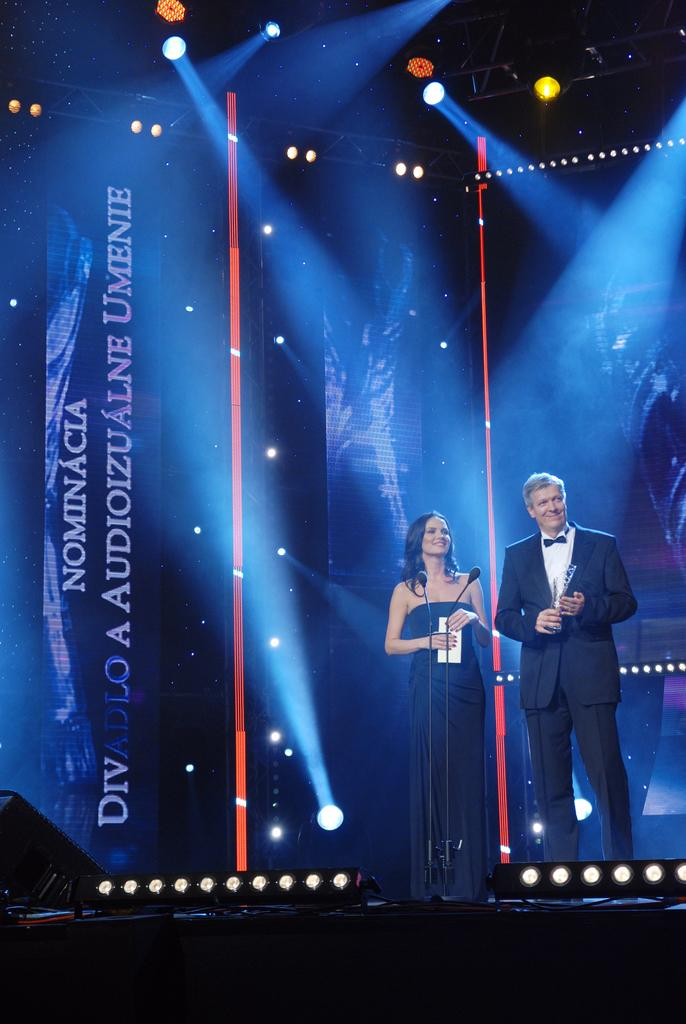What is the man on stage wearing? The man on stage is wearing a black jacket. What is the lady on stage wearing? The lady on stage is wearing a black dress. Can you describe the appearance of the lady? The lady is stunning. What equipment is in front of the man and lady on stage? There are microphones in front of the man and lady. What can be seen behind the man and lady on stage? There are posters and lights visible behind the man and lady. How many spiders are crawling on the man's black jacket in the image? There are no spiders visible on the man's black jacket in the image. What scientific experiment is being conducted on stage? There is no scientific experiment being conducted on stage; the man and lady are likely performers or speakers. 